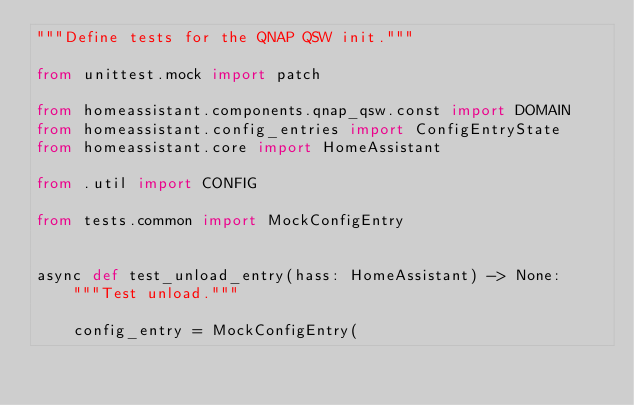<code> <loc_0><loc_0><loc_500><loc_500><_Python_>"""Define tests for the QNAP QSW init."""

from unittest.mock import patch

from homeassistant.components.qnap_qsw.const import DOMAIN
from homeassistant.config_entries import ConfigEntryState
from homeassistant.core import HomeAssistant

from .util import CONFIG

from tests.common import MockConfigEntry


async def test_unload_entry(hass: HomeAssistant) -> None:
    """Test unload."""

    config_entry = MockConfigEntry(</code> 